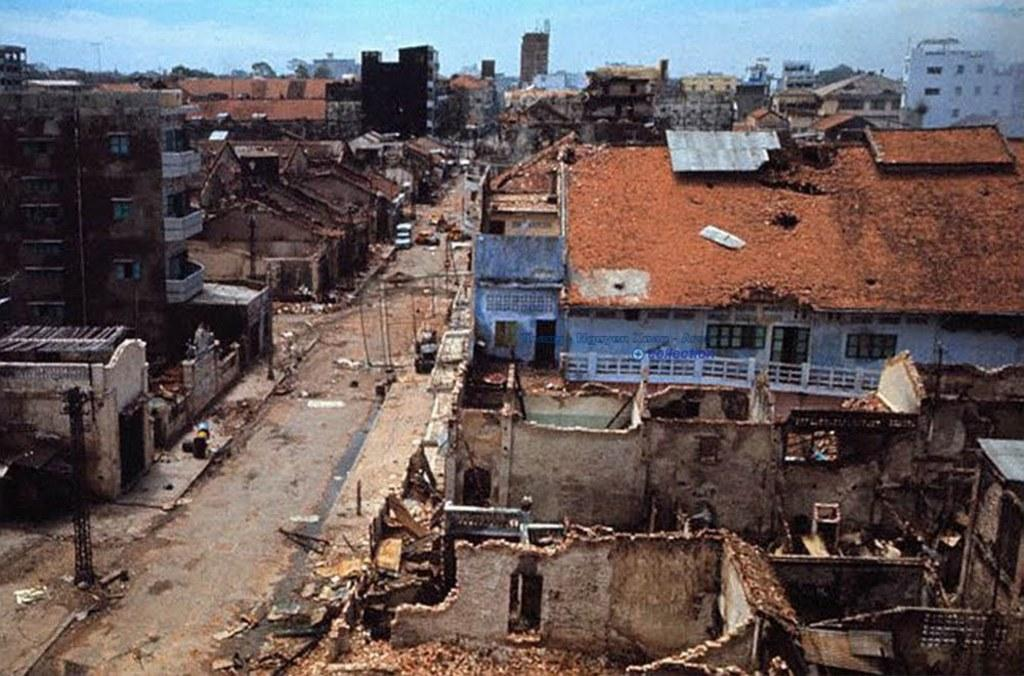What type of structures can be seen in the image? There are buildings with windows and doors in the image. What is happening on the road in the image? There are vehicles on the road in the image. What are the poles used for in the image? The poles are likely used for supporting wires or signs in the image. What else can be seen on the road in the image? There are other objects on the road in the image. What is visible in the background of the image? The sky is visible in the background of the image. Can you tell me where the aunt is saying good-bye in the image? There is no mention of an aunt or any good-byes in the image. The image primarily features buildings, vehicles, poles, and the sky. 